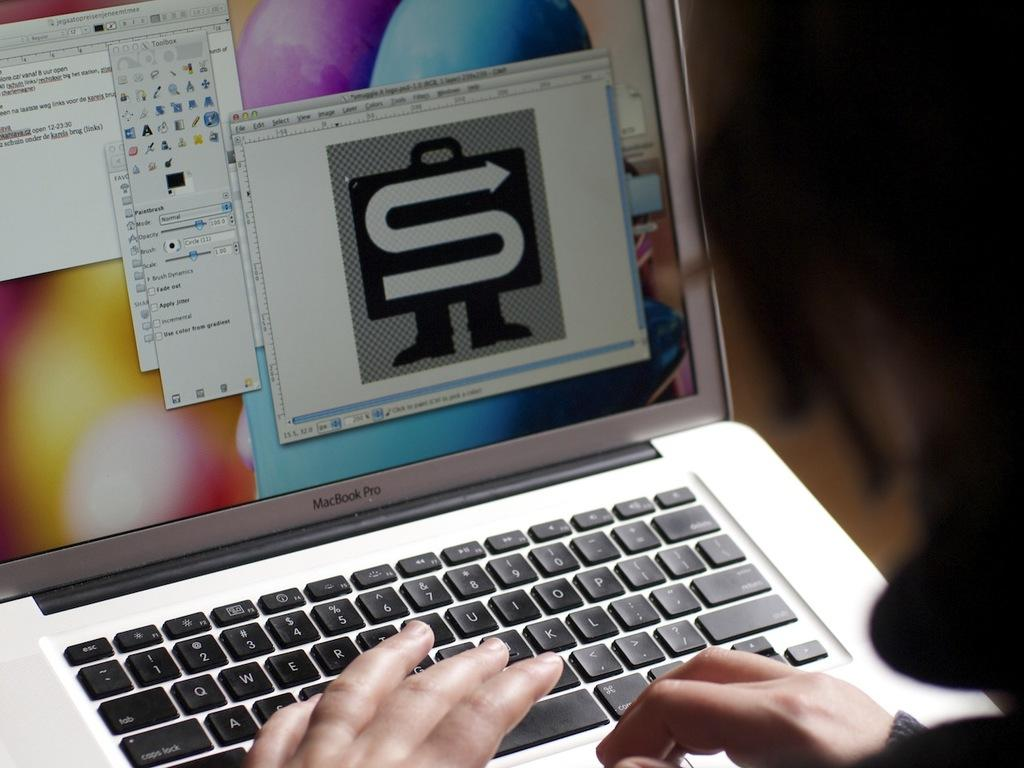<image>
Offer a succinct explanation of the picture presented. Macbook Pro laptop with the toolbox screen pulled up. 